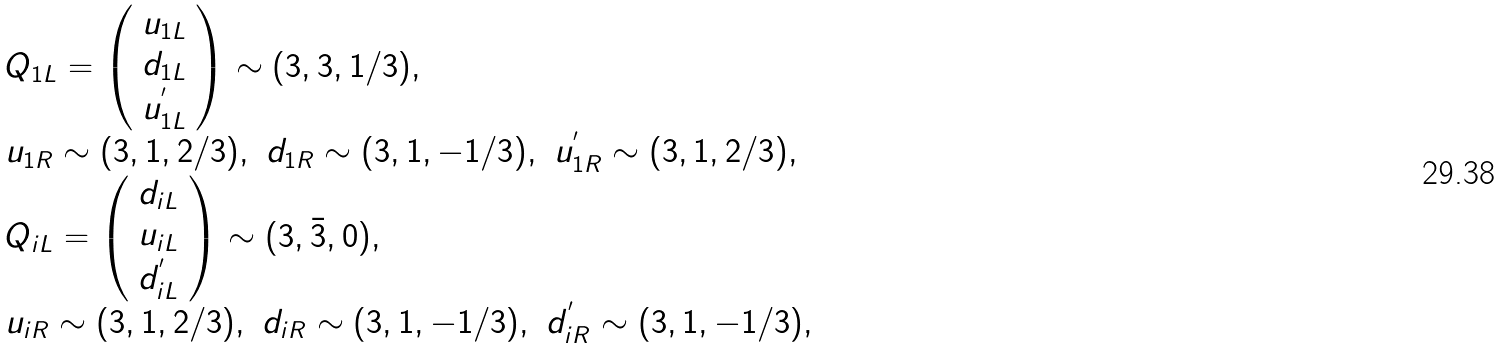<formula> <loc_0><loc_0><loc_500><loc_500>\begin{array} { l } Q _ { 1 L } = \left ( \begin{array} { c } u _ { 1 L } \\ d _ { 1 L } \\ u ^ { ^ { \prime } } _ { 1 L } \end{array} \right ) \sim ( 3 , 3 , 1 / 3 ) , \\ u _ { 1 R } \sim ( 3 , 1 , 2 / 3 ) , \ d _ { 1 R } \sim ( 3 , 1 , - 1 / 3 ) , \ u _ { 1 R } ^ { ^ { \prime } } \sim ( 3 , 1 , 2 / 3 ) , \\ Q _ { i L } = \left ( \begin{array} { c } d _ { i L } \\ u _ { i L } \\ d ^ { ^ { \prime } } _ { i L } \end{array} \right ) \sim ( 3 , \bar { 3 } , 0 ) , \\ u _ { i R } \sim ( 3 , 1 , 2 / 3 ) , \ d _ { i R } \sim ( 3 , 1 , - 1 / 3 ) , \ d _ { i R } ^ { ^ { \prime } } \sim ( 3 , 1 , - 1 / 3 ) , \end{array}</formula> 